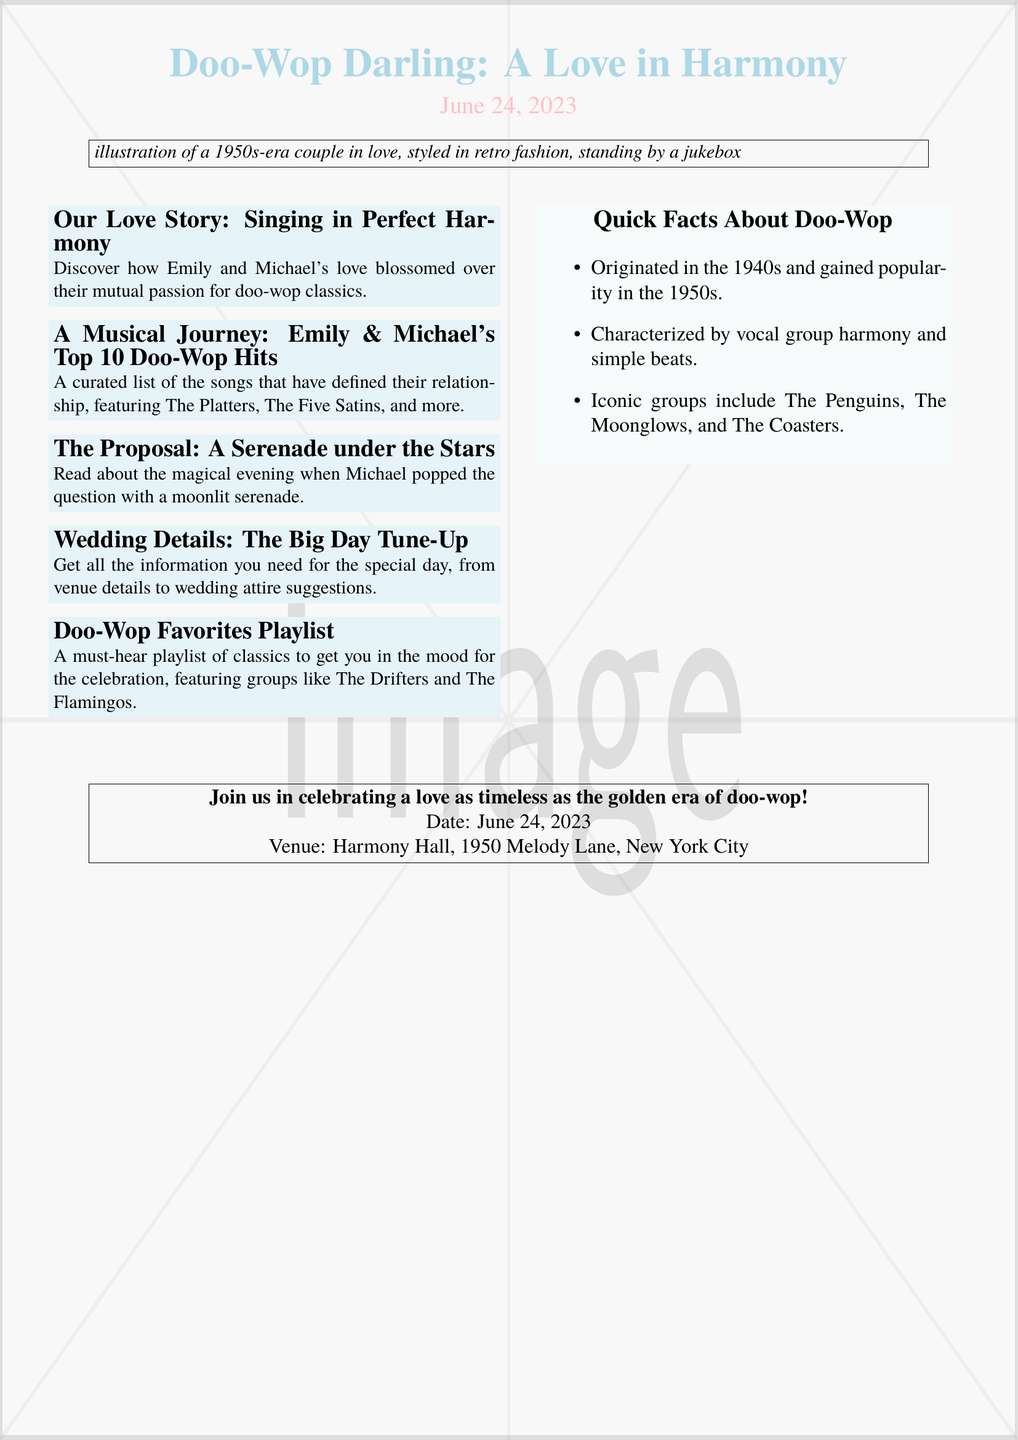What is the date of the wedding? The wedding date is mentioned clearly in the invitation section as June 24, 2023.
Answer: June 24, 2023 What is the venue name? The venue for the wedding is specified as Harmony Hall.
Answer: Harmony Hall Who are the couple featured in the love story? The couple's names mentioned in the document are Emily and Michael.
Answer: Emily and Michael What is highlighted in the "Doo-Wop Favorites Playlist"? The playlist features iconic doo-wop groups such as The Drifters and The Flamingos.
Answer: The Drifters and The Flamingos What is the significance of doo-wop according to the quick facts section? The quick facts mention that doo-wop originated in the 1940s and became popular in the 1950s.
Answer: Originated in the 1940s What did Michael do during the proposal? Michael proposed with a serenade under the stars, as detailed in the proposal section.
Answer: Serenade under the stars How many doo-wop hits are listed in the couple's top 10? The document specifies that a list of top doo-wop hits contains ten songs.
Answer: 10 What color is used for the background? The background color of the document is a retro pink.
Answer: Retro pink What style is the wedding invitation designed after? The invitation is styled as a personalized 1950s music magazine cover.
Answer: 1950s music magazine cover 